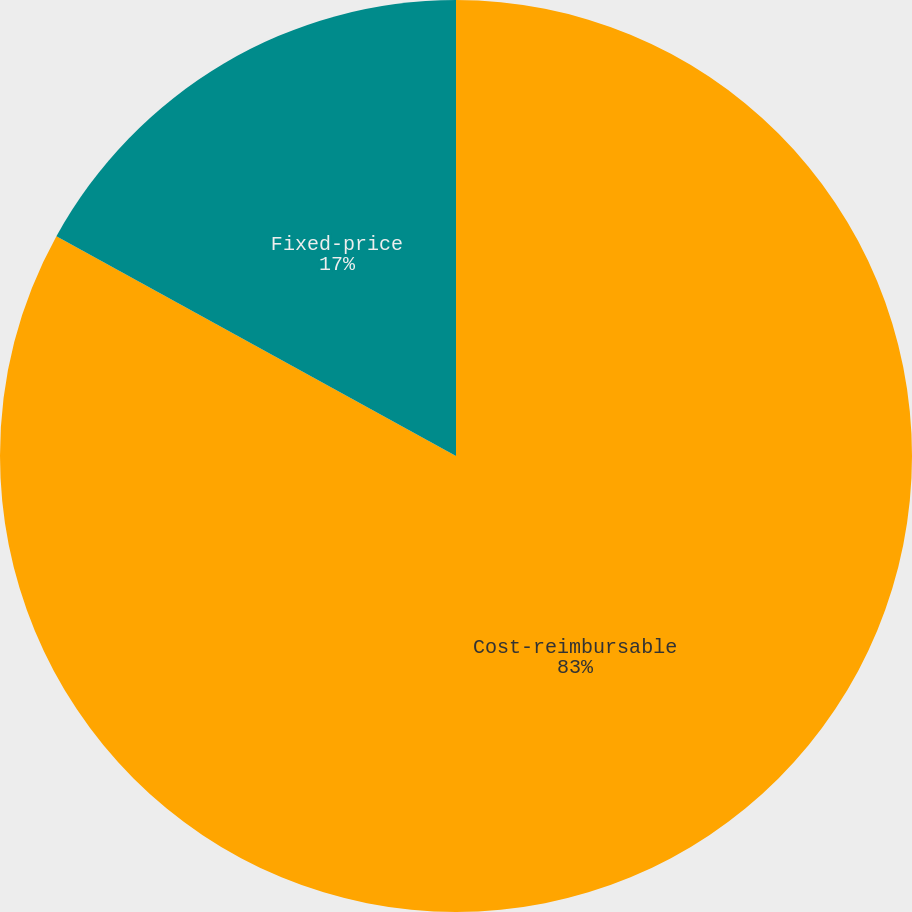Convert chart. <chart><loc_0><loc_0><loc_500><loc_500><pie_chart><fcel>Cost-reimbursable<fcel>Fixed-price<nl><fcel>83.0%<fcel>17.0%<nl></chart> 